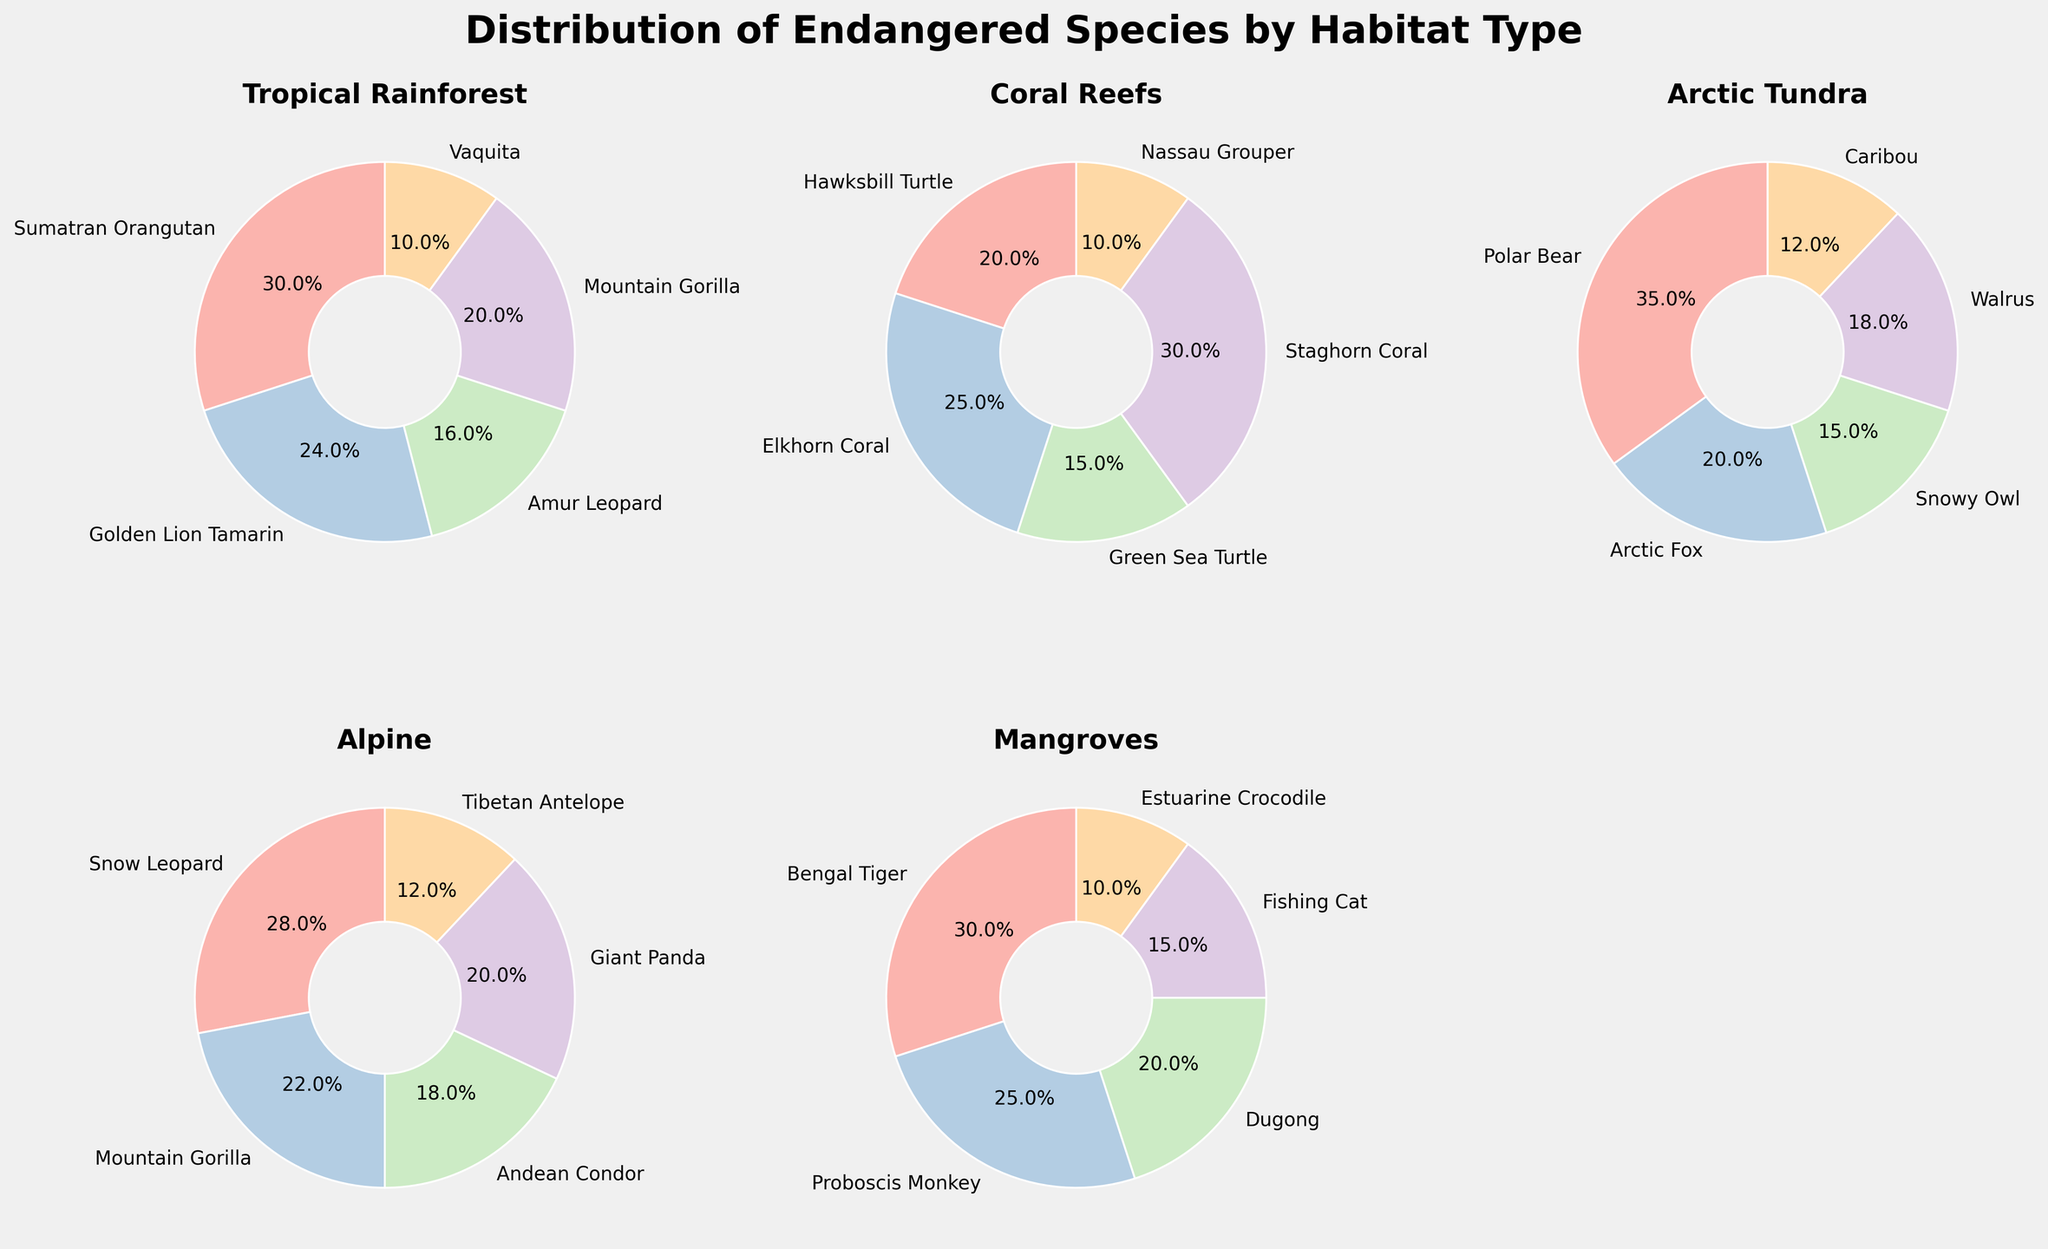Which habitat type hosts the highest percentage of an individual species? By examining the highest percentages in each pie chart, we see that the Polar Bear in the Arctic Tundra has the highest individual species percentage at 35%.
Answer: Arctic Tundra Which habitat type has the most evenly distributed species percentages? By looking at each pie chart, the Tropical Rainforest appears to have the most evenly distributed species percentages, ranging from 5% to 15%.
Answer: Tropical Rainforest How does the percentage of the Mountain Gorilla in the Tropical Rainforest compare to that in the Alpine habitat? The Mountain Gorilla contributes 10% in the Tropical Rainforest but 22% in the Alpine habitat. By directly comparing both values, 22% is greater than 10%.
Answer: 22% What is the combined percentage of the top two species in the Coral Reefs habitat? The top two species in Coral Reefs are Staghorn Coral (30%) and Elkhorn Coral (25%). Their combined percentage is 30% + 25% = 55%.
Answer: 55% Which species appears in more than one habitat type and what are their respective percentages? The Mountain Gorilla appears in both the Tropical Rainforest and Alpine habitats. Its percentages are 10% in Tropical Rainforest and 22% in Alpine.
Answer: Mountain Gorilla: 10% (Tropical Rainforest), 22% (Alpine) What is the average percentage of species in the Mangroves habitat? Summing the percentages in the Mangroves habitat: 30% + 25% + 20% + 15% + 10% = 100%. Dividing by the number of species (5): 100% ÷ 5 = 20%.
Answer: 20% Compare the percentage of the Snow Leopard in the Alpine habitat to the percentage of the Polar Bear in the Arctic Tundra. Which one is higher and by how much? The Snow Leopard has a percentage of 28% in the Alpine habitat and the Polar Bear has 35% in the Arctic Tundra. By comparing these, 35% is higher than 28%, and the difference is 35% - 28% = 7%.
Answer: Polar Bear by 7% Which species in the habitat with the highest total percentage of endangered species has the lowest individual percentage? The Coral Reefs habitat has the highest total percentage with all species summing to 100%. The species with the lowest individual percentage in Coral Reefs is the Nassau Grouper with 10%.
Answer: Nassau Grouper in Coral Reefs 